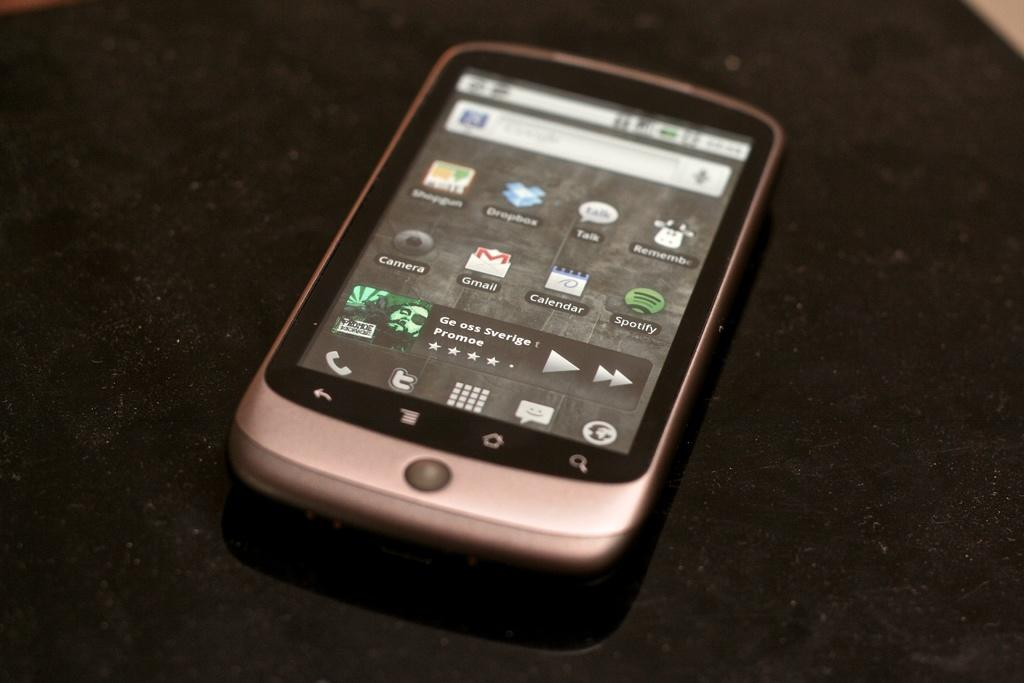What object is the main focus of the image? There is a mobile in the image. What can be seen in the background of the image? There is a dark surface in the background of the image. What rule is being enforced by the mobile in the image? There is no rule being enforced by the mobile in the image, as it is an inanimate object. 